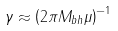<formula> <loc_0><loc_0><loc_500><loc_500>\gamma \approx \left ( 2 \pi M _ { b h } \mu \right ) ^ { - 1 }</formula> 